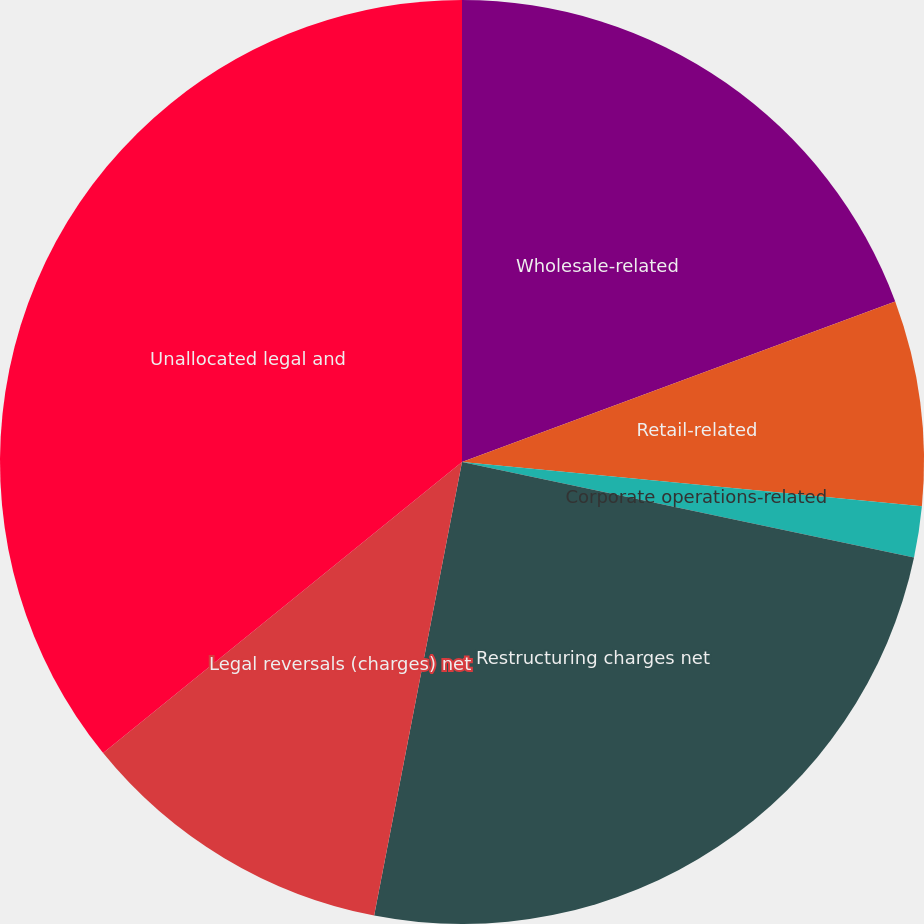<chart> <loc_0><loc_0><loc_500><loc_500><pie_chart><fcel>Wholesale-related<fcel>Retail-related<fcel>Corporate operations-related<fcel>Restructuring charges net<fcel>Legal reversals (charges) net<fcel>Unallocated legal and<nl><fcel>19.35%<fcel>7.17%<fcel>1.79%<fcel>24.73%<fcel>11.11%<fcel>35.84%<nl></chart> 